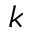Convert formula to latex. <formula><loc_0><loc_0><loc_500><loc_500>k</formula> 